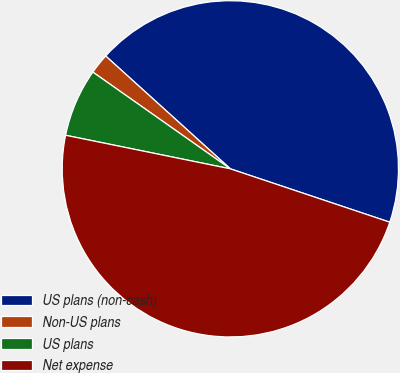Convert chart. <chart><loc_0><loc_0><loc_500><loc_500><pie_chart><fcel>US plans (non-cash)<fcel>Non-US plans<fcel>US plans<fcel>Net expense<nl><fcel>43.43%<fcel>1.95%<fcel>6.56%<fcel>48.06%<nl></chart> 